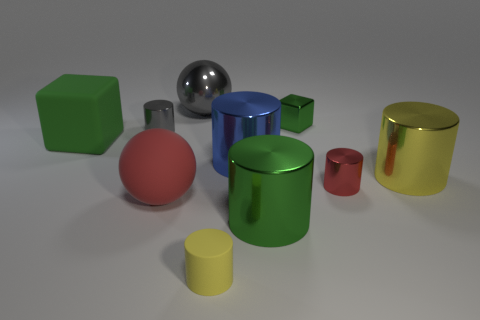Subtract all gray spheres. How many yellow cylinders are left? 2 Subtract 1 cylinders. How many cylinders are left? 5 Subtract all yellow cylinders. How many cylinders are left? 4 Subtract all small yellow cylinders. How many cylinders are left? 5 Subtract all cyan cylinders. Subtract all red blocks. How many cylinders are left? 6 Subtract all cylinders. How many objects are left? 4 Subtract 0 yellow cubes. How many objects are left? 10 Subtract all large shiny balls. Subtract all small purple matte cylinders. How many objects are left? 9 Add 3 big yellow metallic objects. How many big yellow metallic objects are left? 4 Add 3 gray things. How many gray things exist? 5 